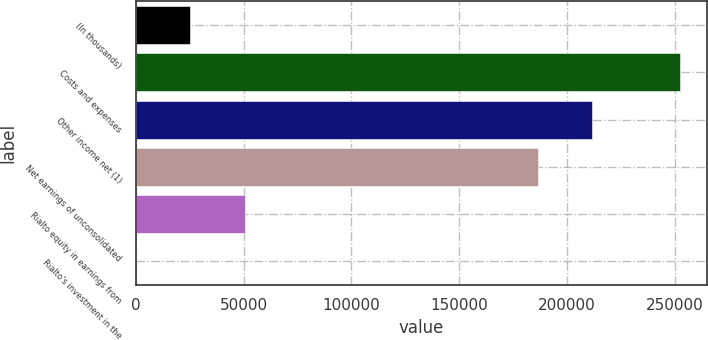Convert chart to OTSL. <chart><loc_0><loc_0><loc_500><loc_500><bar_chart><fcel>(In thousands)<fcel>Costs and expenses<fcel>Other income net (1)<fcel>Net earnings of unconsolidated<fcel>Rialto equity in earnings from<fcel>Rialto's investment in the<nl><fcel>25268<fcel>252563<fcel>211671<fcel>186416<fcel>50523<fcel>13<nl></chart> 